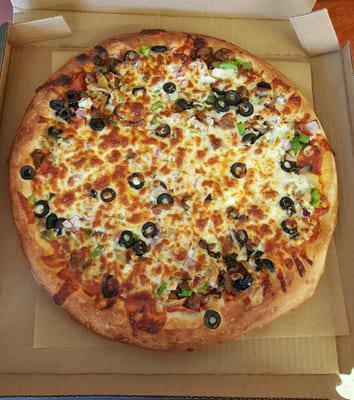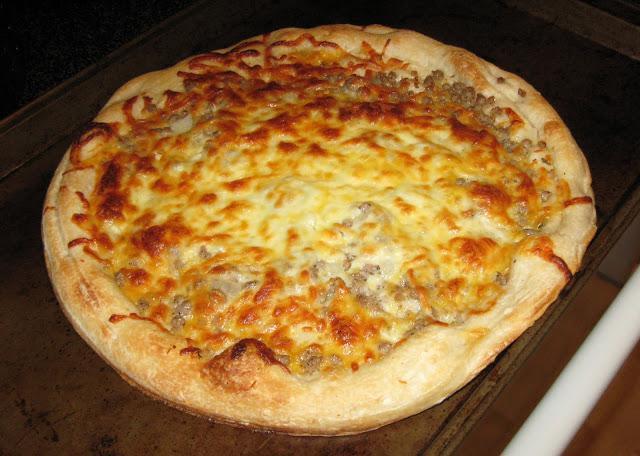The first image is the image on the left, the second image is the image on the right. For the images shown, is this caption "there is a pizza in a carboard box" true? Answer yes or no. Yes. The first image is the image on the left, the second image is the image on the right. Assess this claim about the two images: "Two whole baked pizzas are covered with toppings and melted cheese, one of them in a cardboard delivery box.". Correct or not? Answer yes or no. Yes. 